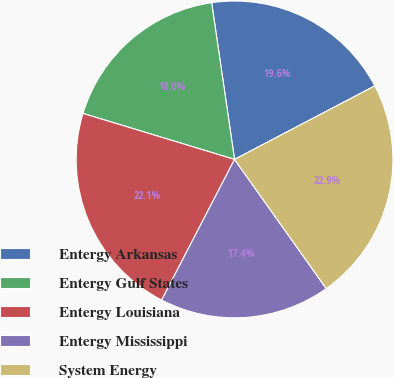Convert chart. <chart><loc_0><loc_0><loc_500><loc_500><pie_chart><fcel>Entergy Arkansas<fcel>Entergy Gulf States<fcel>Entergy Louisiana<fcel>Entergy Mississippi<fcel>System Energy<nl><fcel>19.62%<fcel>18.0%<fcel>22.08%<fcel>17.44%<fcel>22.86%<nl></chart> 